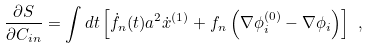Convert formula to latex. <formula><loc_0><loc_0><loc_500><loc_500>\frac { \partial S } { \partial { C } _ { i n } } = \int d t \left [ \dot { f } _ { n } ( t ) a ^ { 2 } \dot { x } ^ { ( 1 ) } + f _ { n } \left ( \nabla \phi ^ { ( 0 ) } _ { i } - \nabla \phi _ { i } \right ) \right ] \ ,</formula> 